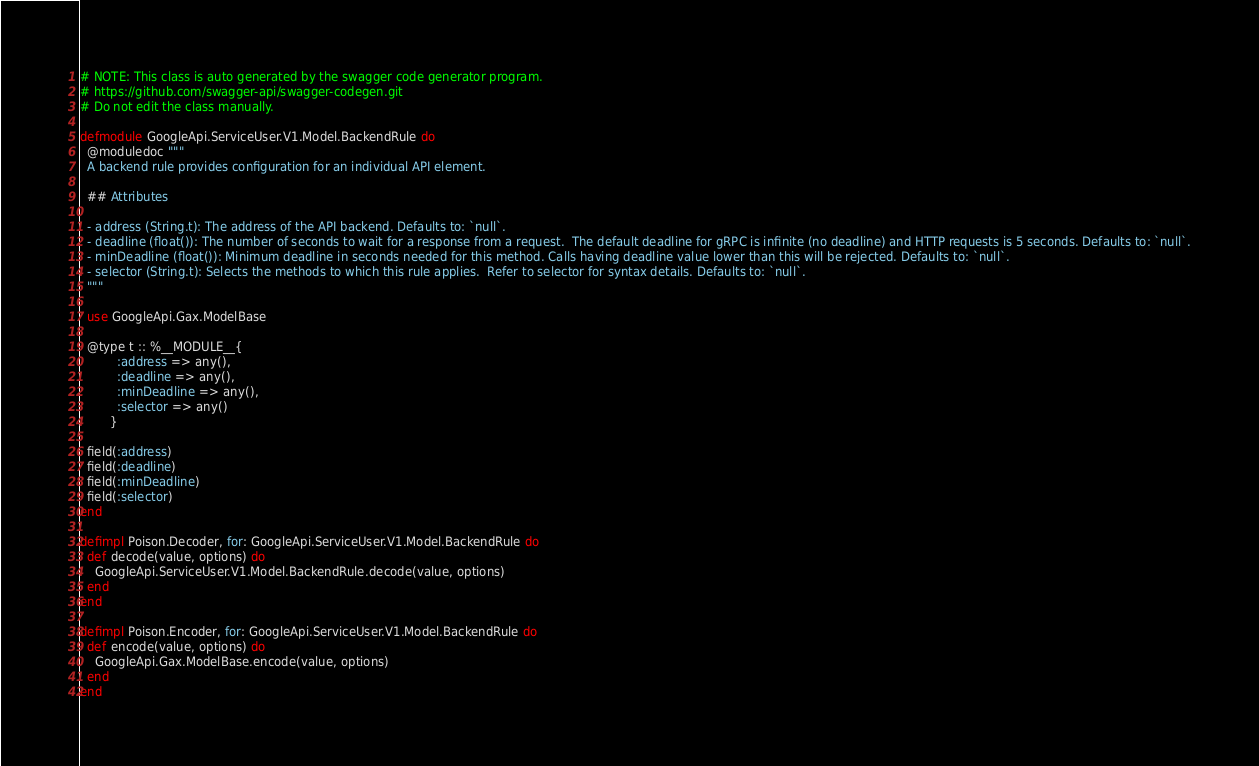<code> <loc_0><loc_0><loc_500><loc_500><_Elixir_># NOTE: This class is auto generated by the swagger code generator program.
# https://github.com/swagger-api/swagger-codegen.git
# Do not edit the class manually.

defmodule GoogleApi.ServiceUser.V1.Model.BackendRule do
  @moduledoc """
  A backend rule provides configuration for an individual API element.

  ## Attributes

  - address (String.t): The address of the API backend. Defaults to: `null`.
  - deadline (float()): The number of seconds to wait for a response from a request.  The default deadline for gRPC is infinite (no deadline) and HTTP requests is 5 seconds. Defaults to: `null`.
  - minDeadline (float()): Minimum deadline in seconds needed for this method. Calls having deadline value lower than this will be rejected. Defaults to: `null`.
  - selector (String.t): Selects the methods to which this rule applies.  Refer to selector for syntax details. Defaults to: `null`.
  """

  use GoogleApi.Gax.ModelBase

  @type t :: %__MODULE__{
          :address => any(),
          :deadline => any(),
          :minDeadline => any(),
          :selector => any()
        }

  field(:address)
  field(:deadline)
  field(:minDeadline)
  field(:selector)
end

defimpl Poison.Decoder, for: GoogleApi.ServiceUser.V1.Model.BackendRule do
  def decode(value, options) do
    GoogleApi.ServiceUser.V1.Model.BackendRule.decode(value, options)
  end
end

defimpl Poison.Encoder, for: GoogleApi.ServiceUser.V1.Model.BackendRule do
  def encode(value, options) do
    GoogleApi.Gax.ModelBase.encode(value, options)
  end
end
</code> 